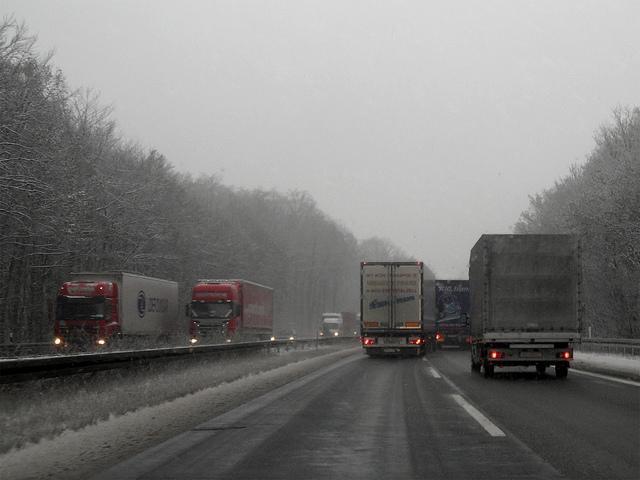How many trucks are not facing the camera?
Give a very brief answer. 3. How many lanes are on this highway?
Give a very brief answer. 2. How many trucks can be seen?
Give a very brief answer. 5. How many people are to the right of the train?
Give a very brief answer. 0. 